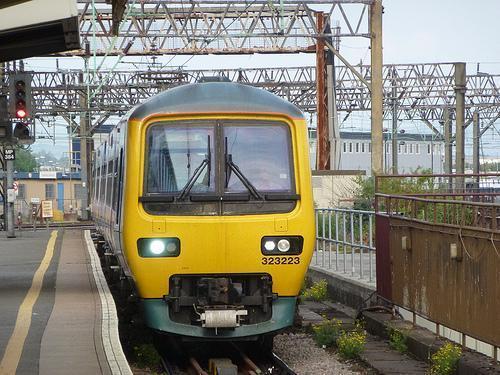How many trains are there?
Give a very brief answer. 1. 